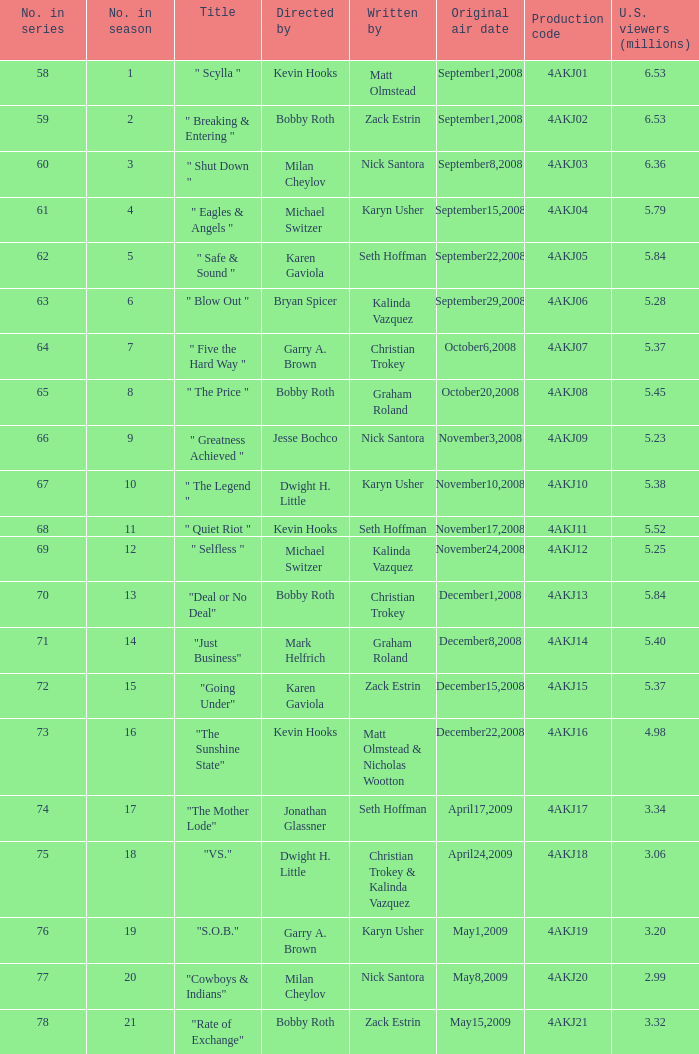Who directed the episode with production code 4akj08? Bobby Roth. 